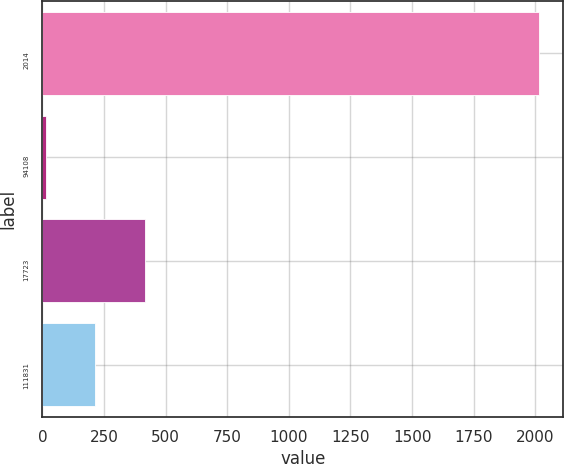Convert chart. <chart><loc_0><loc_0><loc_500><loc_500><bar_chart><fcel>2014<fcel>94108<fcel>17723<fcel>111831<nl><fcel>2013<fcel>15<fcel>414.6<fcel>214.8<nl></chart> 